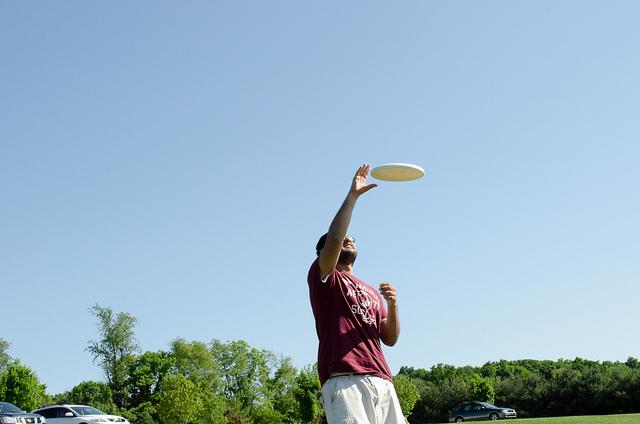Is this a team competition?
Keep it brief. No. What toy is the little boy playing with?
Be succinct. Frisbee. What is the person catching?
Answer briefly. Frisbee. What is this guy doing?
Keep it brief. Playing frisbee. Could the catcher be left-handed?
Keep it brief. Yes. What is in the sky?
Quick response, please. Frisbee. What are the people flying?
Answer briefly. Frisbee. Is the man holding two frisbees?
Answer briefly. No. What color is the frisbee?
Give a very brief answer. White. Is he throwing the Frisbee?
Keep it brief. No. 